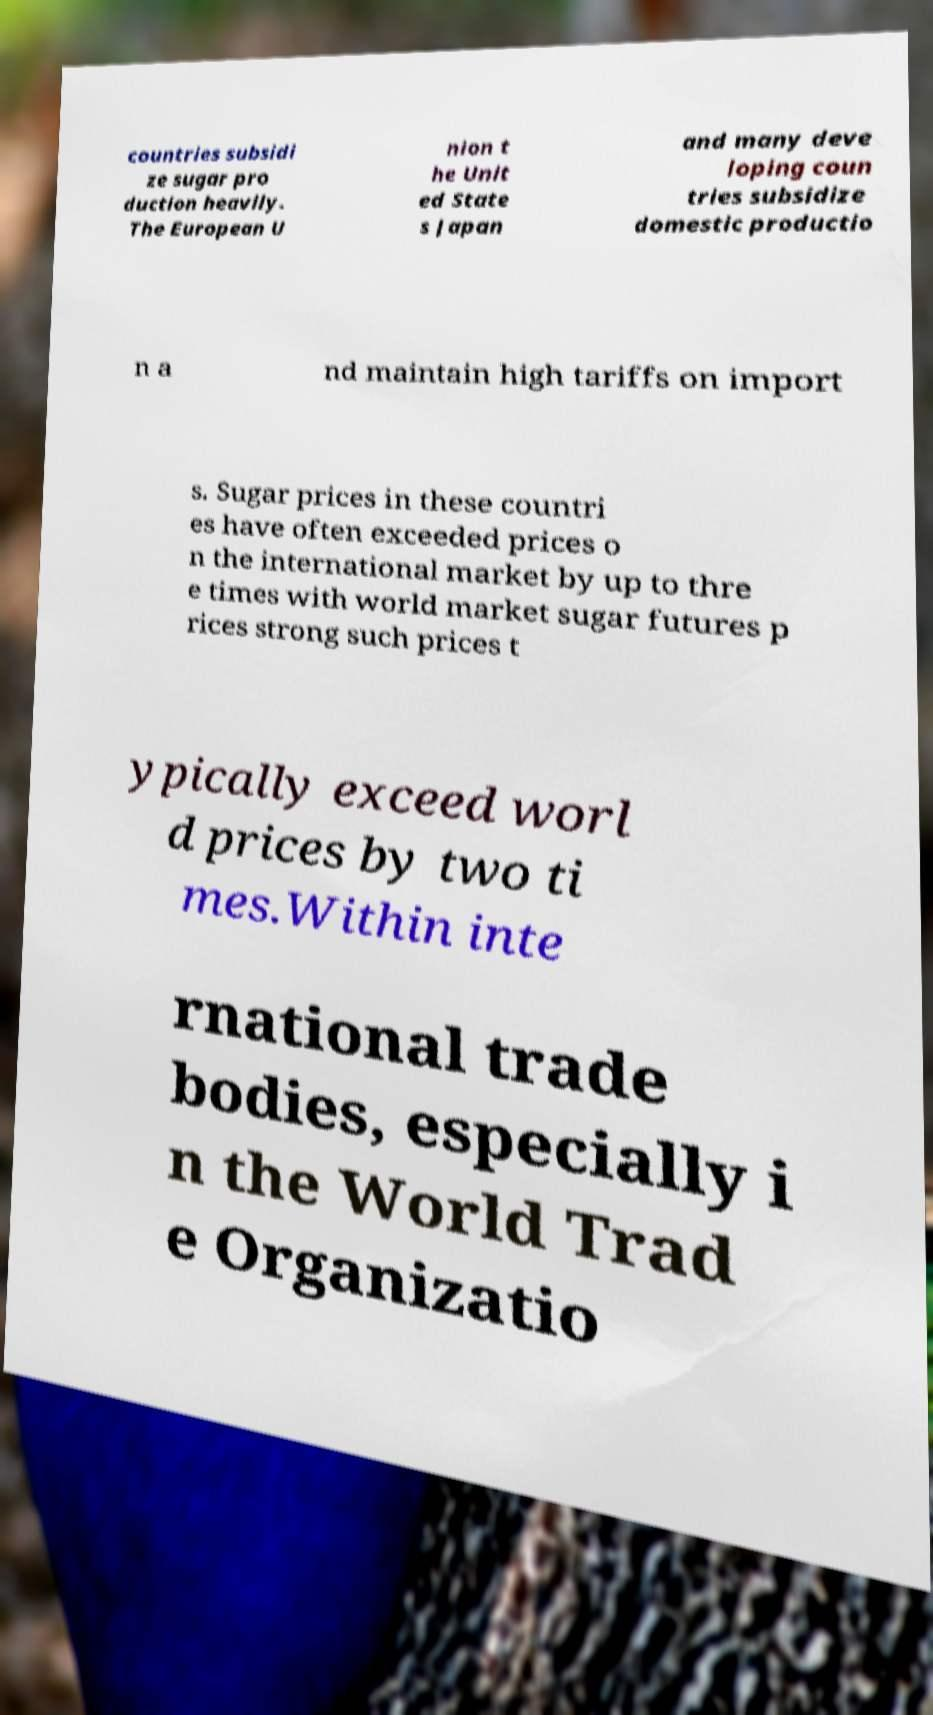Please read and relay the text visible in this image. What does it say? countries subsidi ze sugar pro duction heavily. The European U nion t he Unit ed State s Japan and many deve loping coun tries subsidize domestic productio n a nd maintain high tariffs on import s. Sugar prices in these countri es have often exceeded prices o n the international market by up to thre e times with world market sugar futures p rices strong such prices t ypically exceed worl d prices by two ti mes.Within inte rnational trade bodies, especially i n the World Trad e Organizatio 